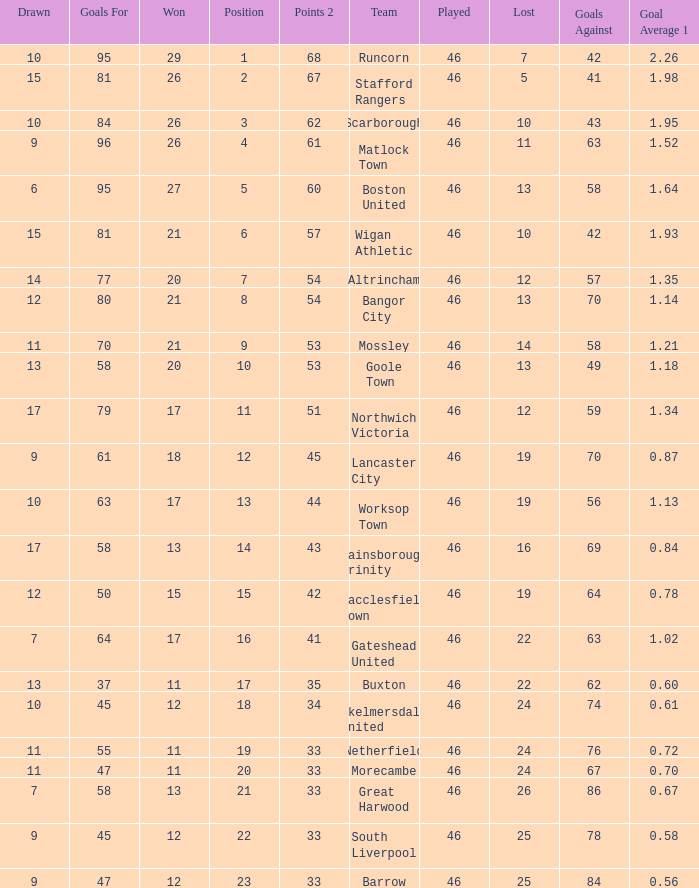What is the highest position of the Bangor City team? 8.0. 